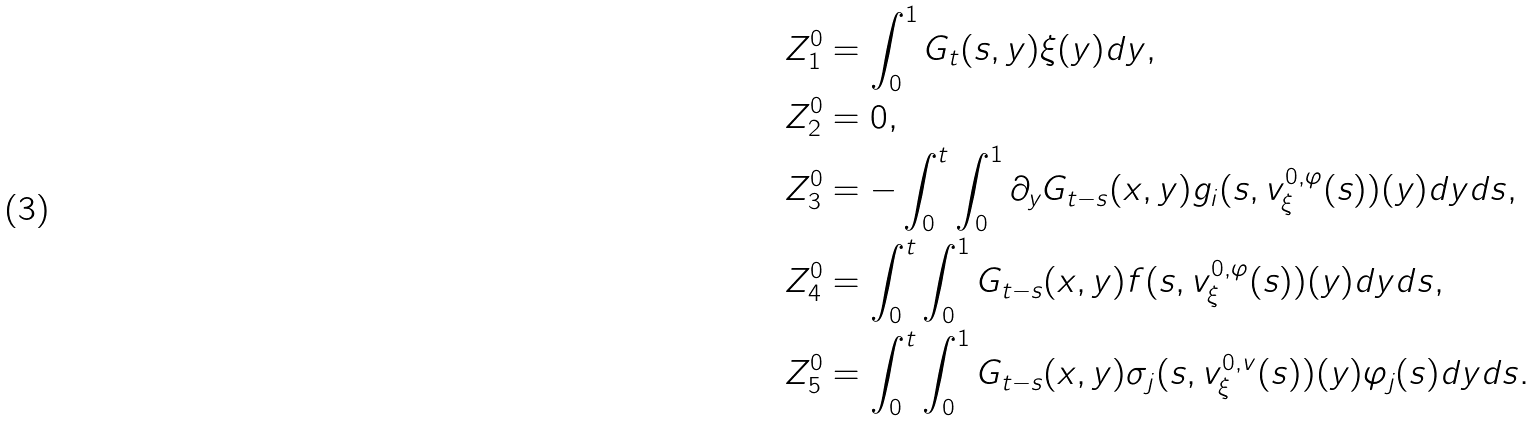<formula> <loc_0><loc_0><loc_500><loc_500>& Z _ { 1 } ^ { 0 } = \int _ { 0 } ^ { 1 } G _ { t } ( s , y ) \xi ( y ) d y , \\ & Z _ { 2 } ^ { 0 } = 0 , \\ & Z _ { 3 } ^ { 0 } = - \int _ { 0 } ^ { t } \int _ { 0 } ^ { 1 } \partial _ { y } G _ { t - s } ( x , y ) g _ { i } ( s , v ^ { { 0 } , \varphi } _ { \xi } ( s ) ) ( y ) d y d s , \\ & Z _ { 4 } ^ { 0 } = \int _ { 0 } ^ { t } \int _ { 0 } ^ { 1 } G _ { t - s } ( x , y ) f ( s , v ^ { { 0 } , \varphi } _ { \xi } ( s ) ) ( y ) d y d s , \\ & Z _ { 5 } ^ { 0 } = \int _ { 0 } ^ { t } \int _ { 0 } ^ { 1 } G _ { t - s } ( x , y ) \sigma _ { j } ( s , v ^ { { 0 } , v } _ { \xi } ( s ) ) ( y ) \varphi _ { j } ( s ) d y d s .</formula> 